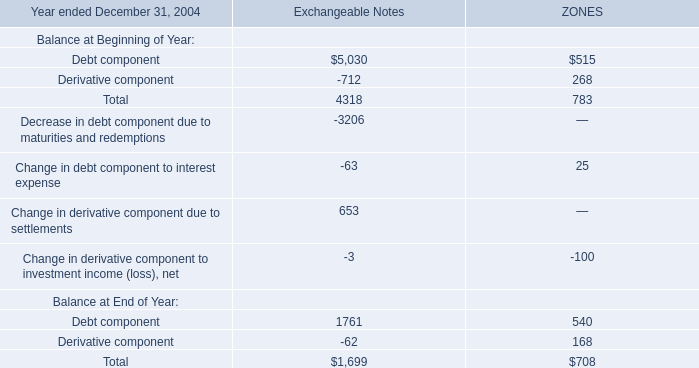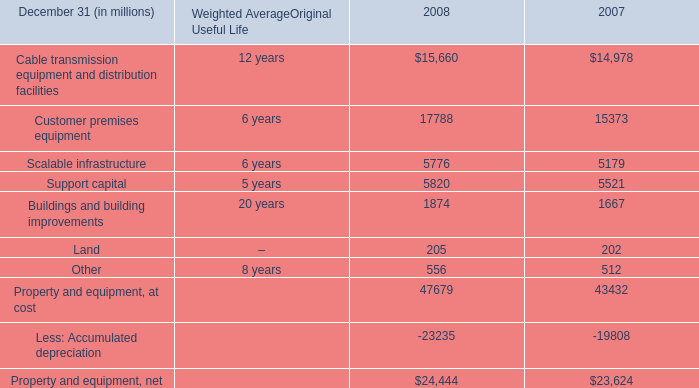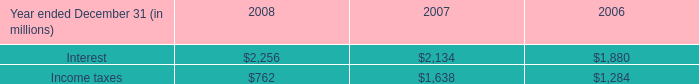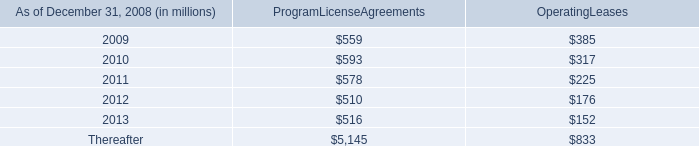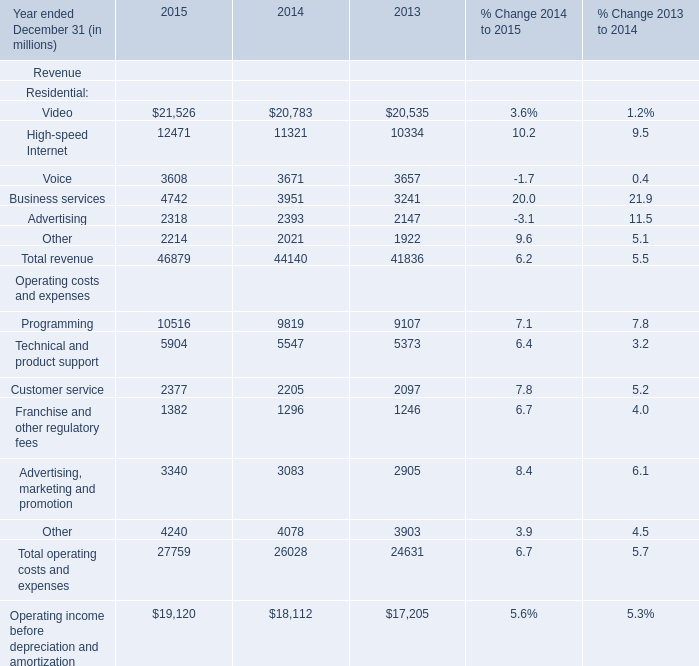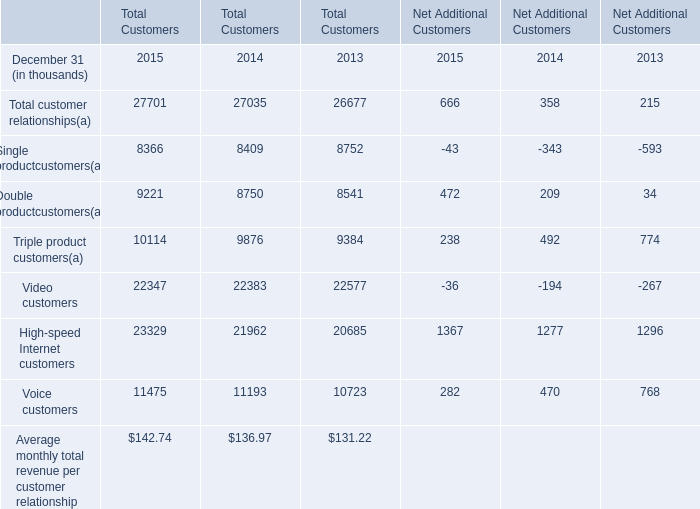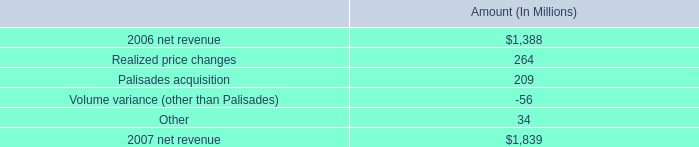How many Net Additional Customers exceed the average of Net Additional Customers in 2015? 
Answer: 3. 